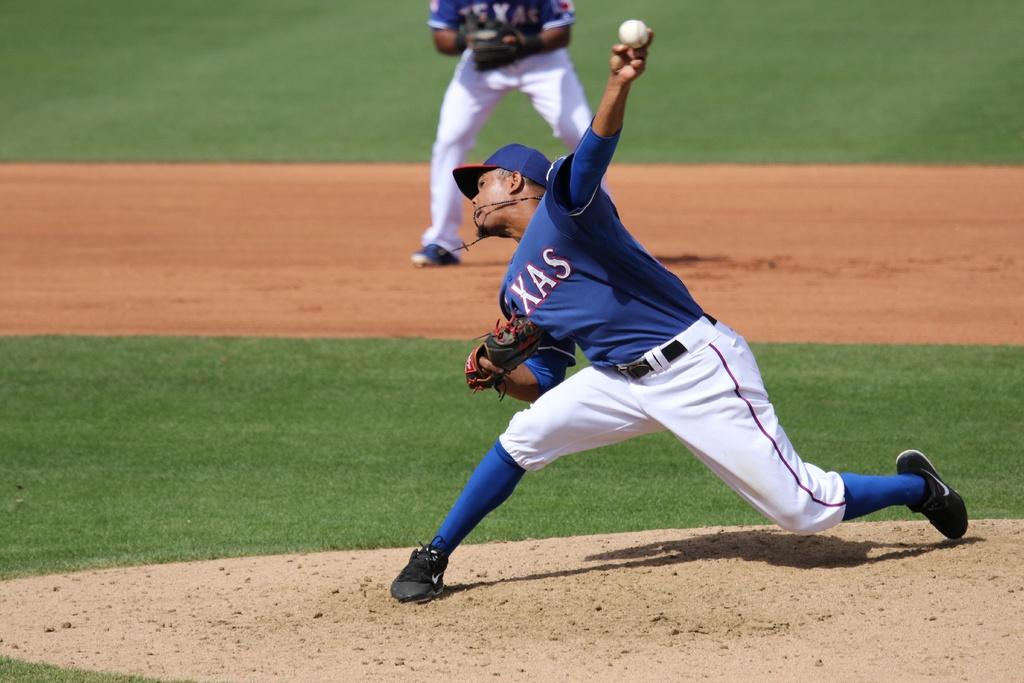<image>
Give a short and clear explanation of the subsequent image. A black fellow in a Texas baseball uniform pitches a ball. 